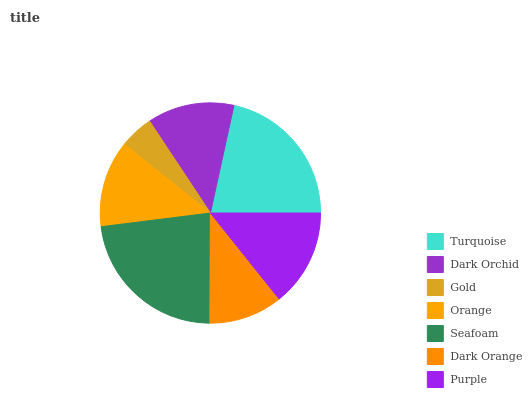Is Gold the minimum?
Answer yes or no. Yes. Is Seafoam the maximum?
Answer yes or no. Yes. Is Dark Orchid the minimum?
Answer yes or no. No. Is Dark Orchid the maximum?
Answer yes or no. No. Is Turquoise greater than Dark Orchid?
Answer yes or no. Yes. Is Dark Orchid less than Turquoise?
Answer yes or no. Yes. Is Dark Orchid greater than Turquoise?
Answer yes or no. No. Is Turquoise less than Dark Orchid?
Answer yes or no. No. Is Dark Orchid the high median?
Answer yes or no. Yes. Is Dark Orchid the low median?
Answer yes or no. Yes. Is Dark Orange the high median?
Answer yes or no. No. Is Turquoise the low median?
Answer yes or no. No. 